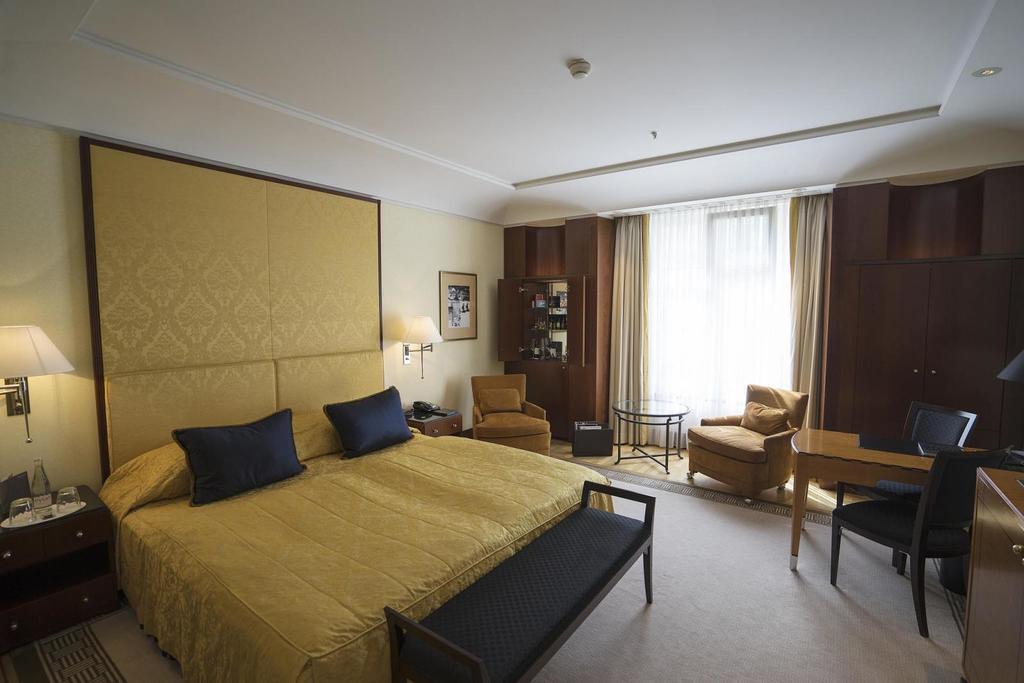Can you describe this image briefly? This is the inside view of a bed room where we can see bed, tables, lamp, sofa, chairs, cupboard. The wall is in yellow color and frame is attached to the wall. The roof is in white color. Right side of the image one brown color almara is there. Beside the almara window is there and curtain is present. 